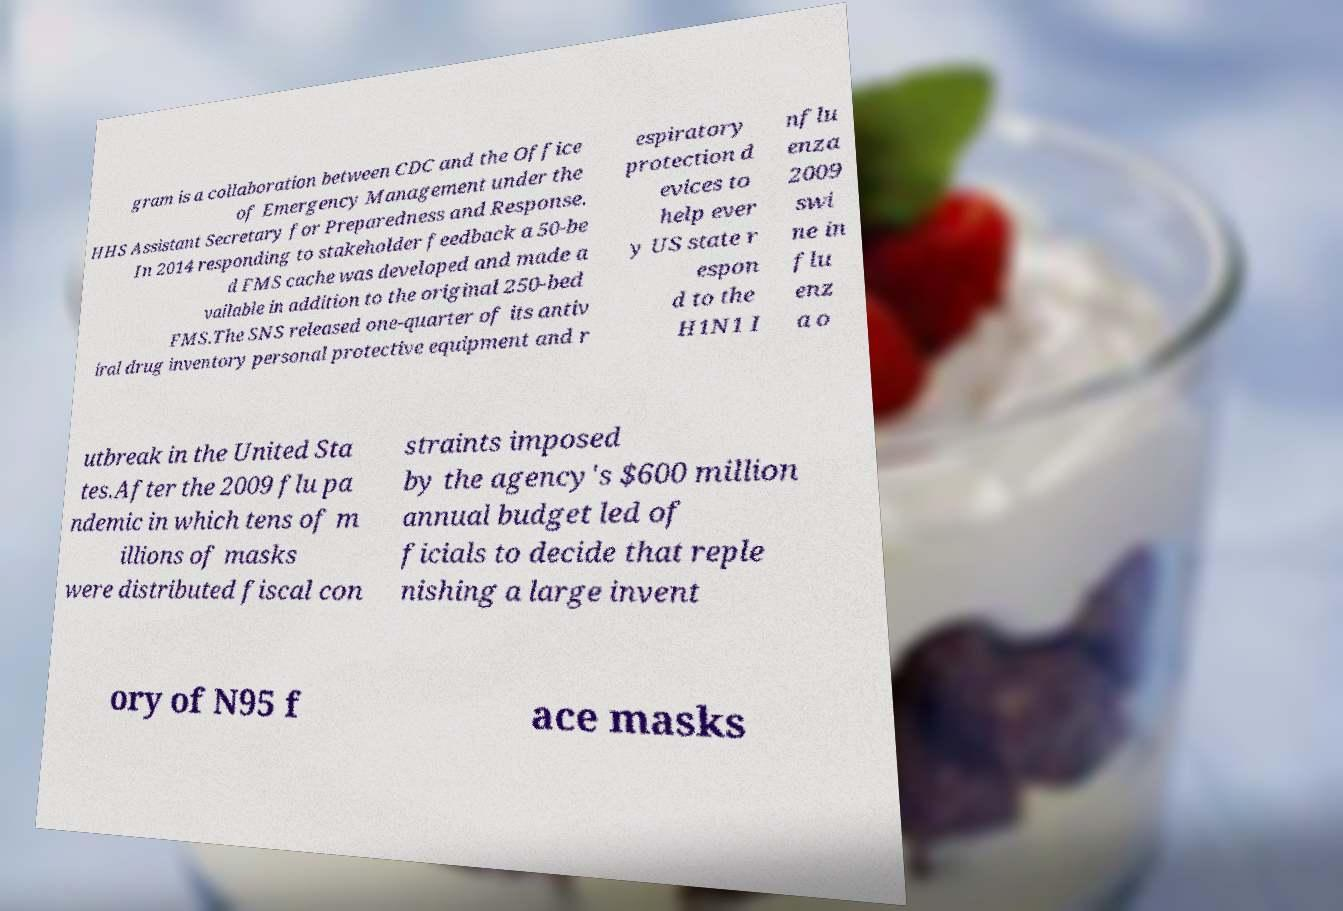Can you accurately transcribe the text from the provided image for me? gram is a collaboration between CDC and the Office of Emergency Management under the HHS Assistant Secretary for Preparedness and Response. In 2014 responding to stakeholder feedback a 50-be d FMS cache was developed and made a vailable in addition to the original 250-bed FMS.The SNS released one-quarter of its antiv iral drug inventory personal protective equipment and r espiratory protection d evices to help ever y US state r espon d to the H1N1 I nflu enza 2009 swi ne in flu enz a o utbreak in the United Sta tes.After the 2009 flu pa ndemic in which tens of m illions of masks were distributed fiscal con straints imposed by the agency's $600 million annual budget led of ficials to decide that reple nishing a large invent ory of N95 f ace masks 